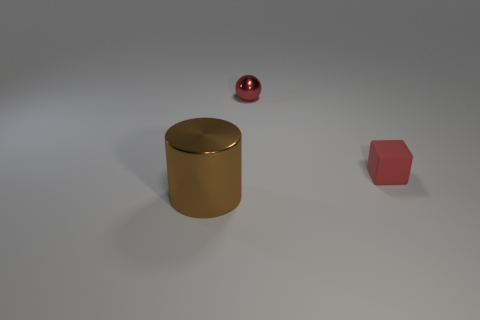Add 1 red matte blocks. How many objects exist? 4 Subtract all spheres. How many objects are left? 2 Subtract all cyan blocks. How many cyan cylinders are left? 0 Subtract all tiny spheres. Subtract all brown cylinders. How many objects are left? 1 Add 2 big objects. How many big objects are left? 3 Add 1 small red spheres. How many small red spheres exist? 2 Subtract 0 blue balls. How many objects are left? 3 Subtract 1 spheres. How many spheres are left? 0 Subtract all yellow blocks. Subtract all gray balls. How many blocks are left? 1 